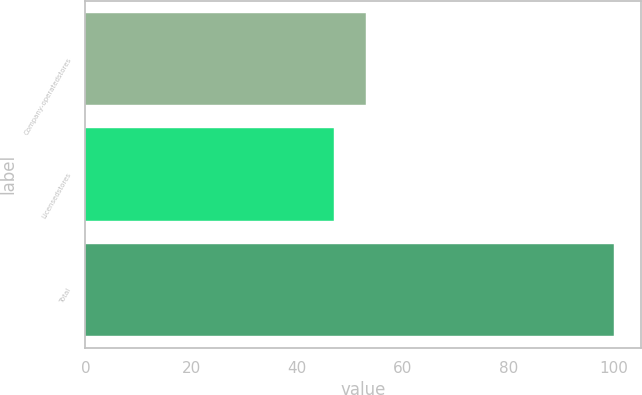Convert chart. <chart><loc_0><loc_0><loc_500><loc_500><bar_chart><fcel>Company-operatedstores<fcel>Licensedstores<fcel>Total<nl><fcel>53<fcel>47<fcel>100<nl></chart> 